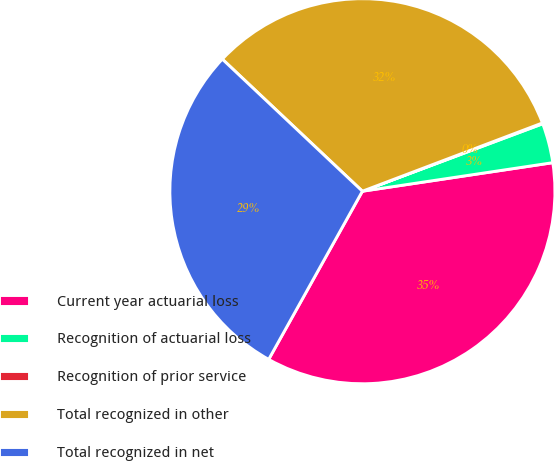Convert chart. <chart><loc_0><loc_0><loc_500><loc_500><pie_chart><fcel>Current year actuarial loss<fcel>Recognition of actuarial loss<fcel>Recognition of prior service<fcel>Total recognized in other<fcel>Total recognized in net<nl><fcel>35.46%<fcel>3.33%<fcel>0.07%<fcel>32.2%<fcel>28.94%<nl></chart> 